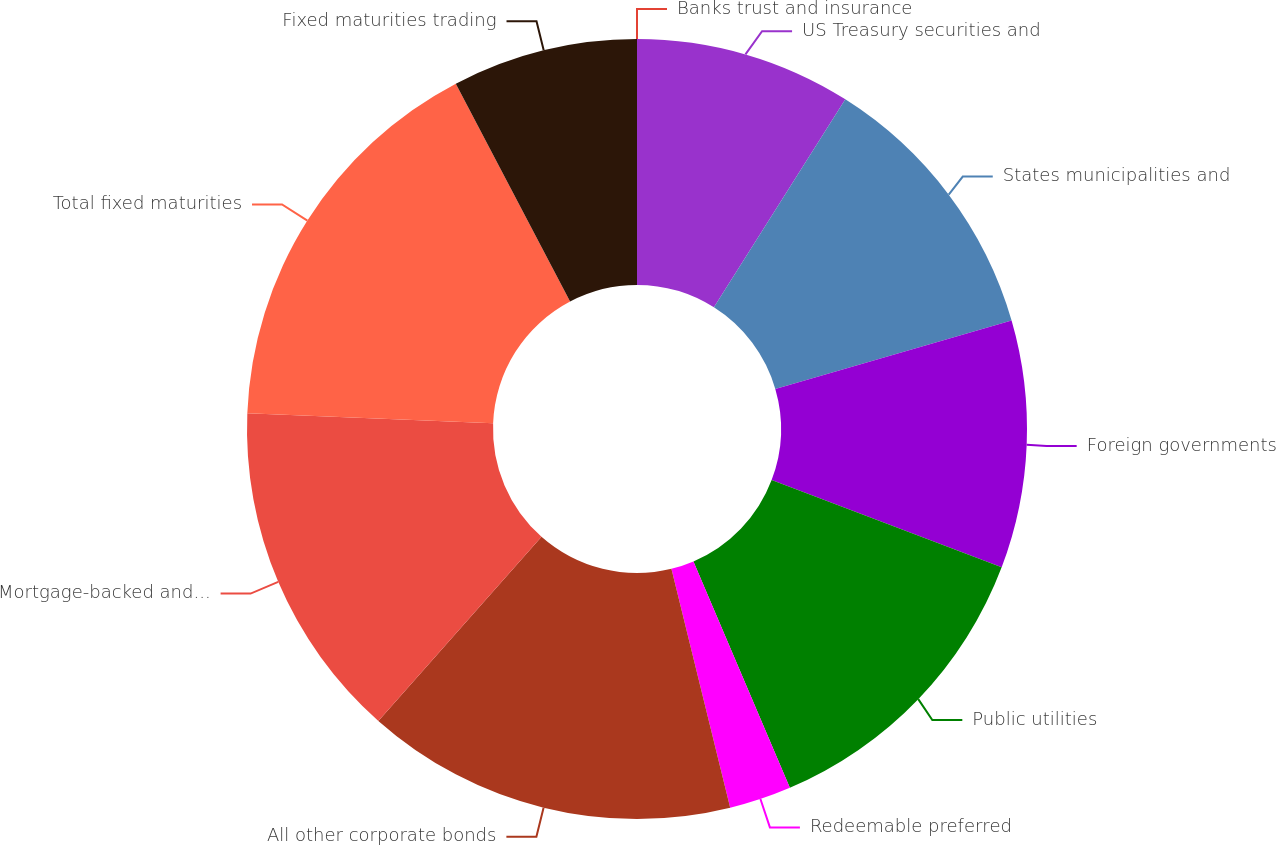Convert chart. <chart><loc_0><loc_0><loc_500><loc_500><pie_chart><fcel>US Treasury securities and<fcel>States municipalities and<fcel>Foreign governments<fcel>Public utilities<fcel>Redeemable preferred<fcel>All other corporate bonds<fcel>Mortgage-backed and other<fcel>Total fixed maturities<fcel>Fixed maturities trading<fcel>Banks trust and insurance<nl><fcel>8.97%<fcel>11.54%<fcel>10.26%<fcel>12.82%<fcel>2.57%<fcel>15.38%<fcel>14.1%<fcel>16.67%<fcel>7.69%<fcel>0.0%<nl></chart> 